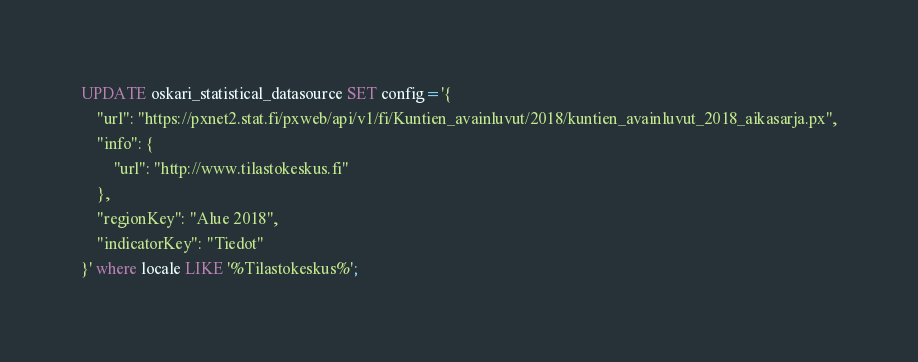<code> <loc_0><loc_0><loc_500><loc_500><_SQL_>UPDATE oskari_statistical_datasource SET config='{
	"url": "https://pxnet2.stat.fi/pxweb/api/v1/fi/Kuntien_avainluvut/2018/kuntien_avainluvut_2018_aikasarja.px",
	"info": {
		"url": "http://www.tilastokeskus.fi"
	},
	"regionKey": "Alue 2018",
	"indicatorKey": "Tiedot"
}' where locale LIKE '%Tilastokeskus%';</code> 